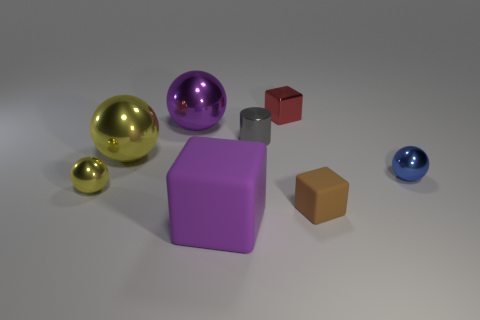Subtract all green blocks. How many yellow spheres are left? 2 Subtract all blue balls. How many balls are left? 3 Add 1 gray matte cylinders. How many objects exist? 9 Subtract all cylinders. How many objects are left? 7 Subtract 1 cylinders. How many cylinders are left? 0 Subtract 0 gray blocks. How many objects are left? 8 Subtract all red balls. Subtract all yellow cylinders. How many balls are left? 4 Subtract all gray cylinders. Subtract all tiny blue cylinders. How many objects are left? 7 Add 6 brown things. How many brown things are left? 7 Add 2 large brown shiny cubes. How many large brown shiny cubes exist? 2 